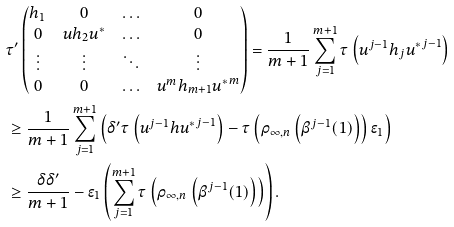Convert formula to latex. <formula><loc_0><loc_0><loc_500><loc_500>& \tau ^ { \prime } \left ( \begin{matrix} h _ { 1 } & 0 & \hdots & 0 \\ 0 & u h _ { 2 } u ^ { * } & \hdots & 0 \\ \vdots & \vdots & \ddots & \vdots \\ 0 & 0 & \hdots & u ^ { m } h _ { m + 1 } { u ^ { * } } ^ { m } \end{matrix} \right ) = \frac { 1 } { m + 1 } \sum _ { j = 1 } ^ { m + 1 } \tau \left ( u ^ { j - 1 } h _ { j } { u ^ { * } } ^ { j - 1 } \right ) \\ & \geq \frac { 1 } { m + 1 } \sum _ { j = 1 } ^ { m + 1 } \left ( \delta ^ { \prime } { \tau \left ( u ^ { j - 1 } h { u ^ { * } } ^ { j - 1 } \right ) } - \tau \left ( \rho _ { \infty , n } \left ( \beta ^ { j - 1 } ( 1 ) \right ) \right ) \epsilon _ { 1 } \right ) \\ & \geq \frac { \delta \delta ^ { \prime } } { m + 1 } - \epsilon _ { 1 } \left ( \sum _ { j = 1 } ^ { m + 1 } \tau \left ( \rho _ { \infty , n } \left ( \beta ^ { j - 1 } ( 1 ) \right ) \right ) \right ) .</formula> 